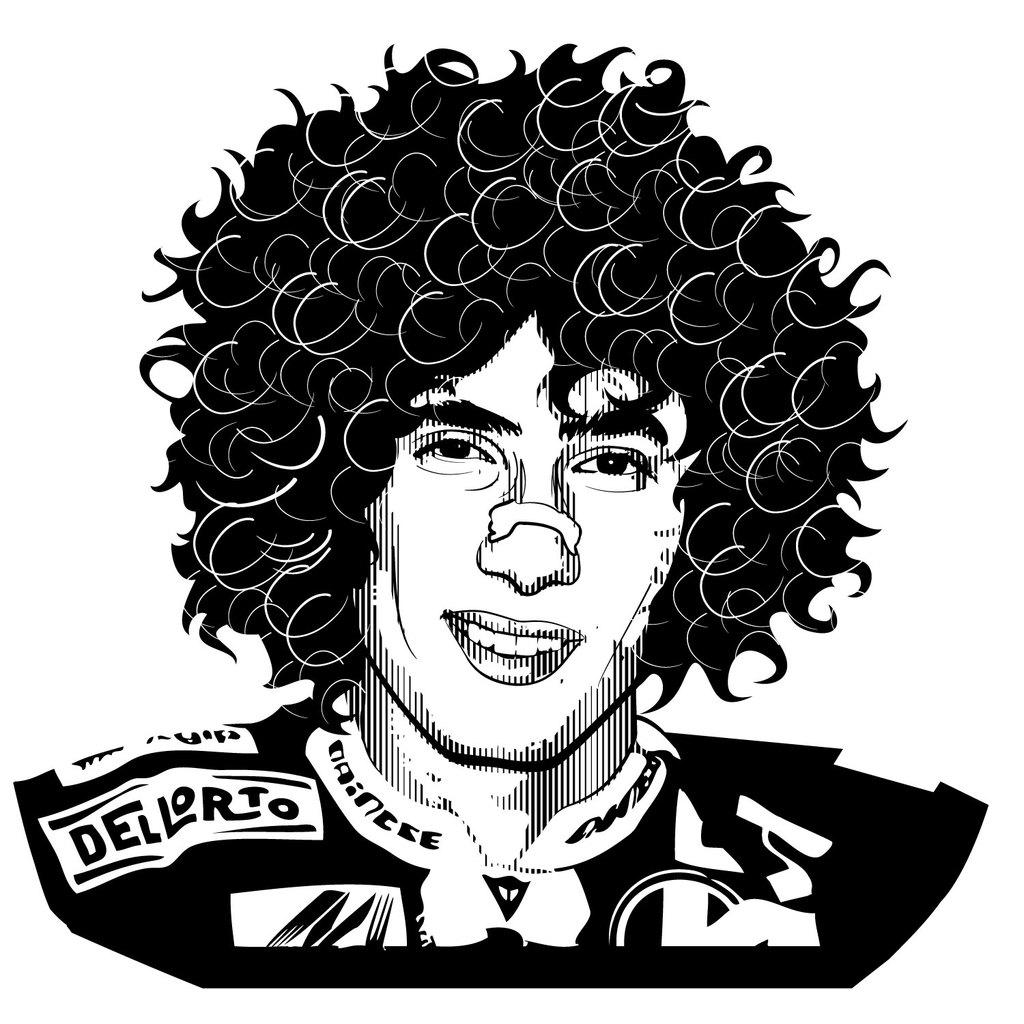What type of image is present in the picture? There is a black and white photo in the image. What is depicted in the photo? The photo is of a person. What type of locket is hanging from the person's neck in the photo? There is no locket visible in the photo, as it only depicts a person. 